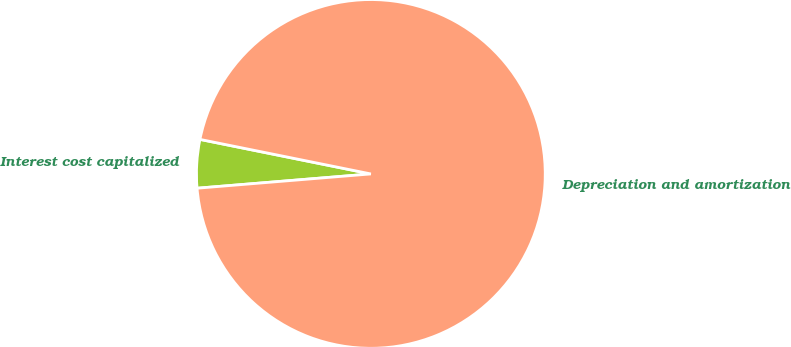Convert chart. <chart><loc_0><loc_0><loc_500><loc_500><pie_chart><fcel>Interest cost capitalized<fcel>Depreciation and amortization<nl><fcel>4.48%<fcel>95.52%<nl></chart> 